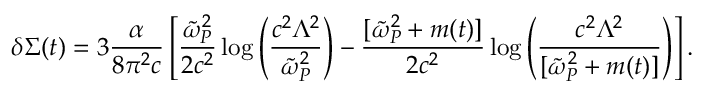<formula> <loc_0><loc_0><loc_500><loc_500>\delta \Sigma ( t ) = { 3 } \frac { \alpha } { { 8 } \pi ^ { 2 } c } \left [ \frac { \tilde { \omega } _ { P } ^ { 2 } } { 2 c ^ { 2 } } \log \left ( \frac { c ^ { 2 } \Lambda ^ { 2 } } { \tilde { \omega } _ { P } ^ { 2 } } \right ) - \frac { [ \tilde { \omega } _ { P } ^ { 2 } + m ( t ) ] } { 2 c ^ { 2 } } \log \left ( \frac { c ^ { 2 } \Lambda ^ { 2 } } { [ \tilde { \omega } _ { P } ^ { 2 } + m ( t ) ] } \right ) \right ] .</formula> 